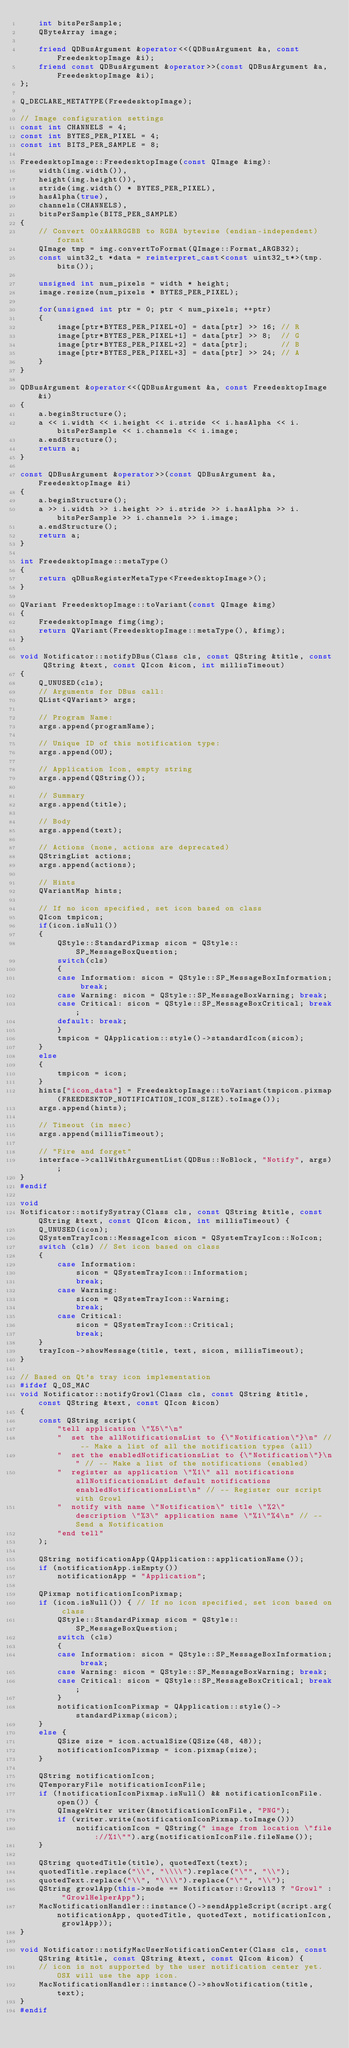<code> <loc_0><loc_0><loc_500><loc_500><_C++_>    int bitsPerSample;
    QByteArray image;

    friend QDBusArgument &operator<<(QDBusArgument &a, const FreedesktopImage &i);
    friend const QDBusArgument &operator>>(const QDBusArgument &a, FreedesktopImage &i);
};

Q_DECLARE_METATYPE(FreedesktopImage);

// Image configuration settings
const int CHANNELS = 4;
const int BYTES_PER_PIXEL = 4;
const int BITS_PER_SAMPLE = 8;

FreedesktopImage::FreedesktopImage(const QImage &img):
    width(img.width()),
    height(img.height()),
    stride(img.width() * BYTES_PER_PIXEL),
    hasAlpha(true),
    channels(CHANNELS),
    bitsPerSample(BITS_PER_SAMPLE)
{
    // Convert 00xAARRGGBB to RGBA bytewise (endian-independent) format
    QImage tmp = img.convertToFormat(QImage::Format_ARGB32);
    const uint32_t *data = reinterpret_cast<const uint32_t*>(tmp.bits());

    unsigned int num_pixels = width * height;
    image.resize(num_pixels * BYTES_PER_PIXEL);

    for(unsigned int ptr = 0; ptr < num_pixels; ++ptr)
    {
        image[ptr*BYTES_PER_PIXEL+0] = data[ptr] >> 16; // R
        image[ptr*BYTES_PER_PIXEL+1] = data[ptr] >> 8;  // G
        image[ptr*BYTES_PER_PIXEL+2] = data[ptr];       // B
        image[ptr*BYTES_PER_PIXEL+3] = data[ptr] >> 24; // A
    }
}

QDBusArgument &operator<<(QDBusArgument &a, const FreedesktopImage &i)
{
    a.beginStructure();
    a << i.width << i.height << i.stride << i.hasAlpha << i.bitsPerSample << i.channels << i.image;
    a.endStructure();
    return a;
}

const QDBusArgument &operator>>(const QDBusArgument &a, FreedesktopImage &i)
{
    a.beginStructure();
    a >> i.width >> i.height >> i.stride >> i.hasAlpha >> i.bitsPerSample >> i.channels >> i.image;
    a.endStructure();
    return a;
}

int FreedesktopImage::metaType()
{
    return qDBusRegisterMetaType<FreedesktopImage>();
}

QVariant FreedesktopImage::toVariant(const QImage &img)
{
    FreedesktopImage fimg(img);
    return QVariant(FreedesktopImage::metaType(), &fimg);
}

void Notificator::notifyDBus(Class cls, const QString &title, const QString &text, const QIcon &icon, int millisTimeout)
{
    Q_UNUSED(cls);
    // Arguments for DBus call:
    QList<QVariant> args;

    // Program Name:
    args.append(programName);

    // Unique ID of this notification type:
    args.append(0U);

    // Application Icon, empty string
    args.append(QString());

    // Summary
    args.append(title);

    // Body
    args.append(text);

    // Actions (none, actions are deprecated)
    QStringList actions;
    args.append(actions);

    // Hints
    QVariantMap hints;

    // If no icon specified, set icon based on class
    QIcon tmpicon;
    if(icon.isNull())
    {
        QStyle::StandardPixmap sicon = QStyle::SP_MessageBoxQuestion;
        switch(cls)
        {
        case Information: sicon = QStyle::SP_MessageBoxInformation; break;
        case Warning: sicon = QStyle::SP_MessageBoxWarning; break;
        case Critical: sicon = QStyle::SP_MessageBoxCritical; break;
        default: break;
        }
        tmpicon = QApplication::style()->standardIcon(sicon);
    }
    else
    {
        tmpicon = icon;
    }
    hints["icon_data"] = FreedesktopImage::toVariant(tmpicon.pixmap(FREEDESKTOP_NOTIFICATION_ICON_SIZE).toImage());
    args.append(hints);

    // Timeout (in msec)
    args.append(millisTimeout);

    // "Fire and forget"
    interface->callWithArgumentList(QDBus::NoBlock, "Notify", args);
}
#endif

void
Notificator::notifySystray(Class cls, const QString &title, const QString &text, const QIcon &icon, int millisTimeout) {
    Q_UNUSED(icon);
    QSystemTrayIcon::MessageIcon sicon = QSystemTrayIcon::NoIcon;
    switch (cls) // Set icon based on class
    {
        case Information:
            sicon = QSystemTrayIcon::Information;
            break;
        case Warning:
            sicon = QSystemTrayIcon::Warning;
            break;
        case Critical:
            sicon = QSystemTrayIcon::Critical;
            break;
    }
    trayIcon->showMessage(title, text, sicon, millisTimeout);
}

// Based on Qt's tray icon implementation
#ifdef Q_OS_MAC
void Notificator::notifyGrowl(Class cls, const QString &title, const QString &text, const QIcon &icon)
{
    const QString script(
        "tell application \"%5\"\n"
        "  set the allNotificationsList to {\"Notification\"}\n" // -- Make a list of all the notification types (all)
        "  set the enabledNotificationsList to {\"Notification\"}\n" // -- Make a list of the notifications (enabled)
        "  register as application \"%1\" all notifications allNotificationsList default notifications enabledNotificationsList\n" // -- Register our script with Growl
        "  notify with name \"Notification\" title \"%2\" description \"%3\" application name \"%1\"%4\n" // -- Send a Notification
        "end tell"
    );

    QString notificationApp(QApplication::applicationName());
    if (notificationApp.isEmpty())
        notificationApp = "Application";

    QPixmap notificationIconPixmap;
    if (icon.isNull()) { // If no icon specified, set icon based on class
        QStyle::StandardPixmap sicon = QStyle::SP_MessageBoxQuestion;
        switch (cls)
        {
        case Information: sicon = QStyle::SP_MessageBoxInformation; break;
        case Warning: sicon = QStyle::SP_MessageBoxWarning; break;
        case Critical: sicon = QStyle::SP_MessageBoxCritical; break;
        }
        notificationIconPixmap = QApplication::style()->standardPixmap(sicon);
    }
    else {
        QSize size = icon.actualSize(QSize(48, 48));
        notificationIconPixmap = icon.pixmap(size);
    }

    QString notificationIcon;
    QTemporaryFile notificationIconFile;
    if (!notificationIconPixmap.isNull() && notificationIconFile.open()) {
        QImageWriter writer(&notificationIconFile, "PNG");
        if (writer.write(notificationIconPixmap.toImage()))
            notificationIcon = QString(" image from location \"file://%1\"").arg(notificationIconFile.fileName());
    }

    QString quotedTitle(title), quotedText(text);
    quotedTitle.replace("\\", "\\\\").replace("\"", "\\");
    quotedText.replace("\\", "\\\\").replace("\"", "\\");
    QString growlApp(this->mode == Notificator::Growl13 ? "Growl" : "GrowlHelperApp");
    MacNotificationHandler::instance()->sendAppleScript(script.arg(notificationApp, quotedTitle, quotedText, notificationIcon, growlApp));
}

void Notificator::notifyMacUserNotificationCenter(Class cls, const QString &title, const QString &text, const QIcon &icon) {
    // icon is not supported by the user notification center yet. OSX will use the app icon.
    MacNotificationHandler::instance()->showNotification(title, text);
}
#endif
</code> 